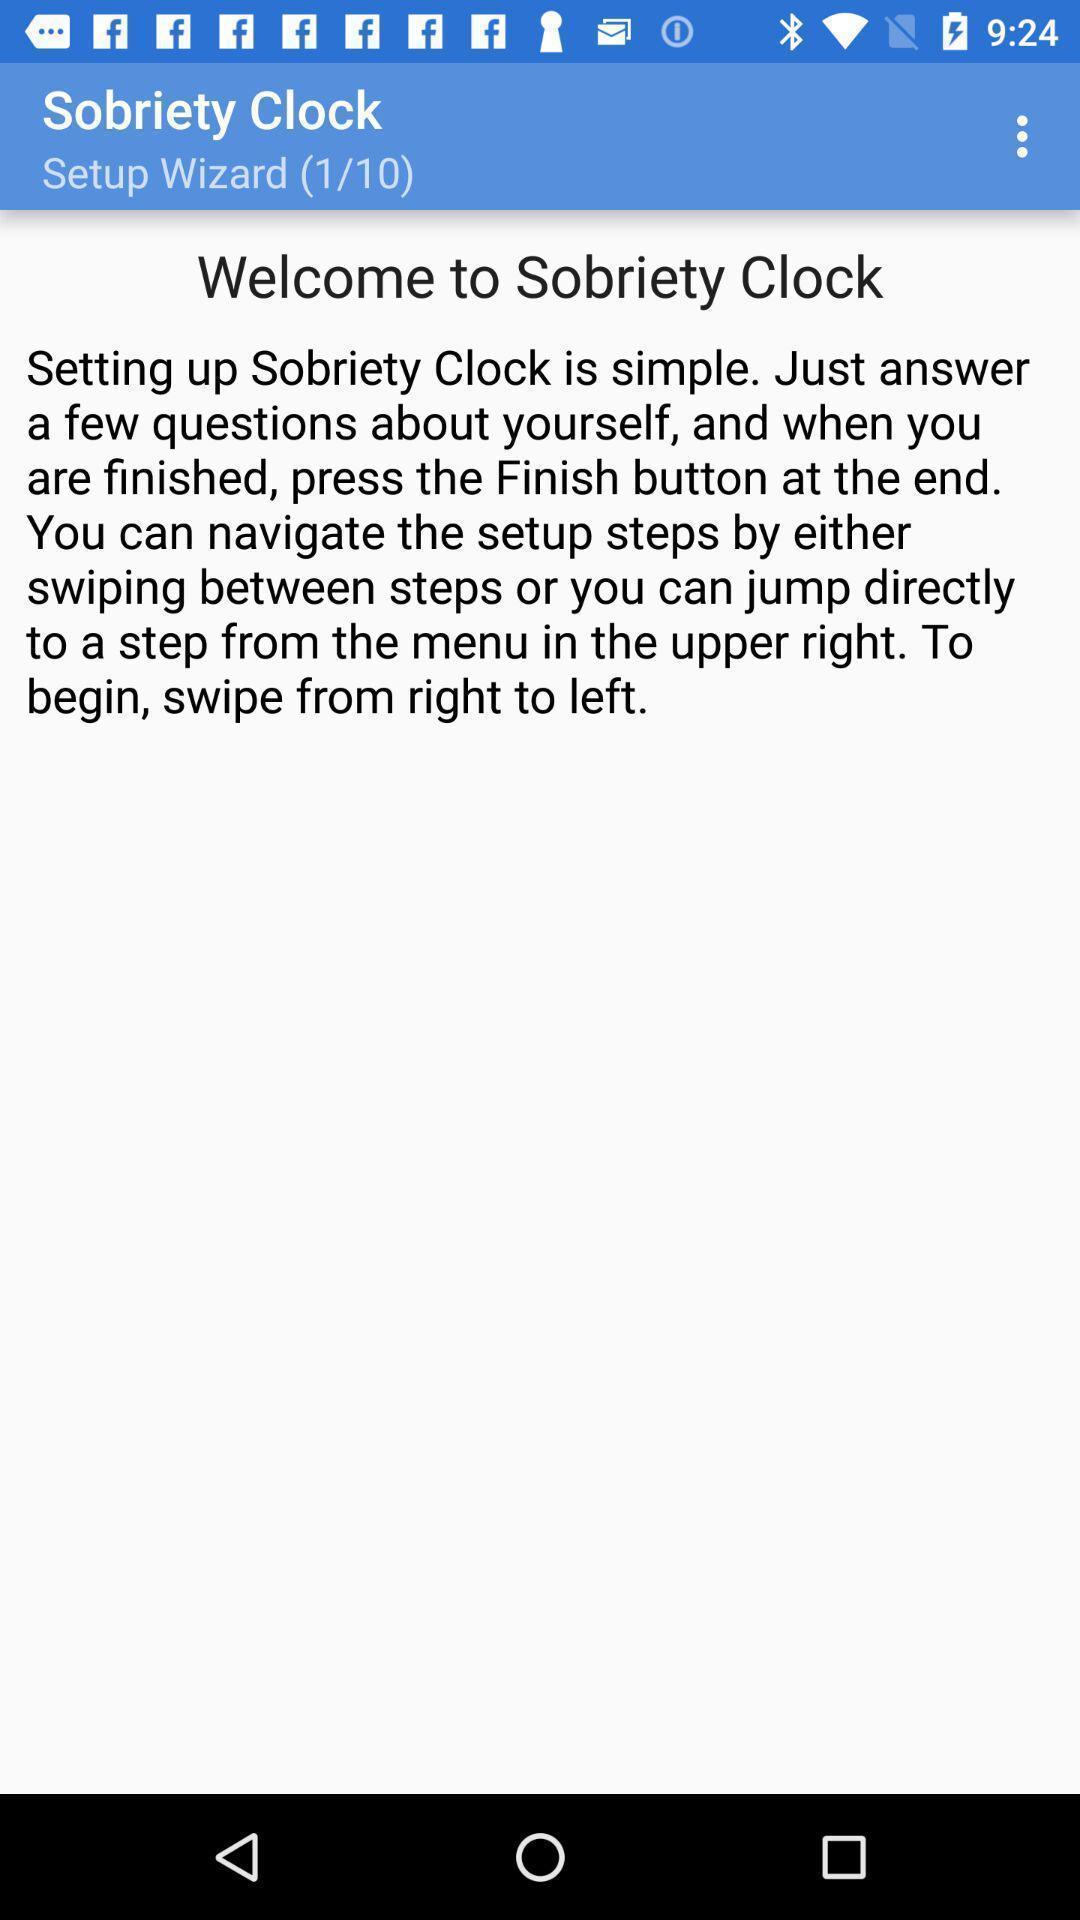What details can you identify in this image? Welcome page of a sobriety app. 